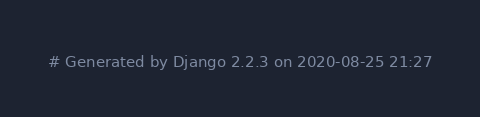<code> <loc_0><loc_0><loc_500><loc_500><_Python_># Generated by Django 2.2.3 on 2020-08-25 21:27
</code> 